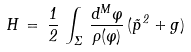<formula> <loc_0><loc_0><loc_500><loc_500>H \, = \, \frac { 1 } { 2 } \, \int _ { \Sigma } \, \frac { d ^ { M } \varphi } { \rho ( \varphi ) } \, ( \vec { p } ^ { \, 2 } + g )</formula> 